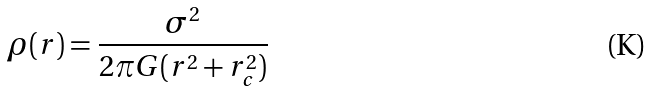<formula> <loc_0><loc_0><loc_500><loc_500>\rho ( r ) = \frac { \sigma ^ { 2 } } { 2 \pi G ( r ^ { 2 } + r _ { c } ^ { 2 } ) }</formula> 